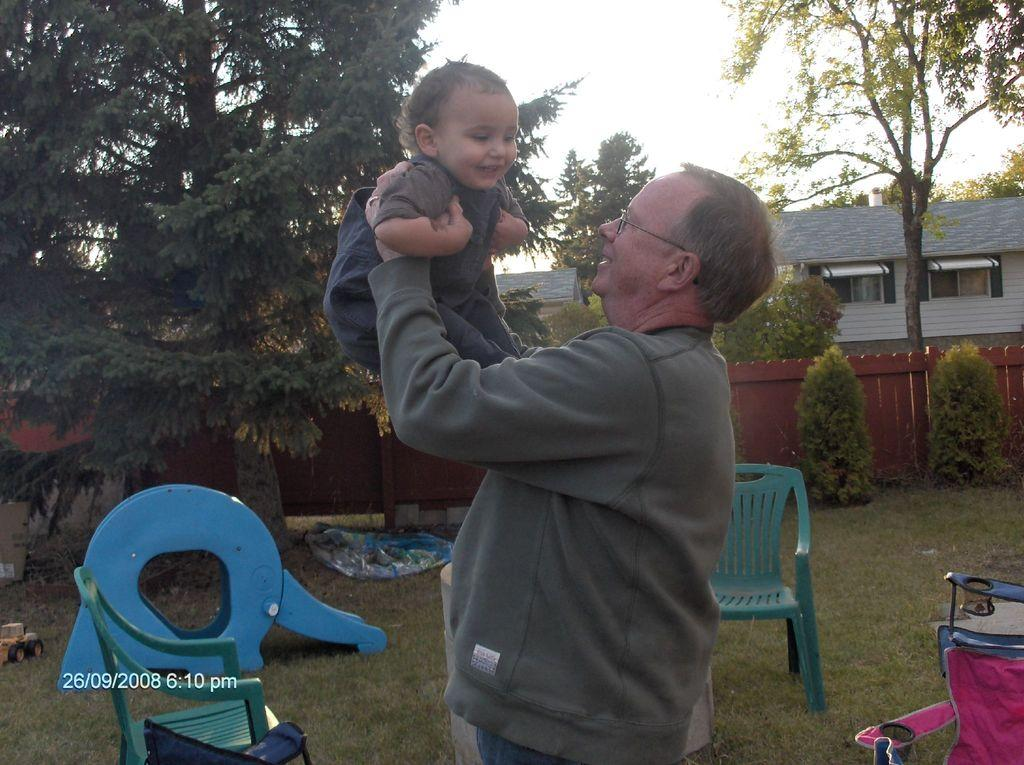What is the person in the image doing? The person is standing and holding a baby. What can be seen in the background of the image? There is a house, trees, plants, and the sky visible in the background. What type of furniture is on the grass? There are chairs on the grass. What other object is on the grass? There is a toy on the grass. What type of knowledge can be gained from the sack in the image? There is no sack present in the image, so no knowledge can be gained from it. 